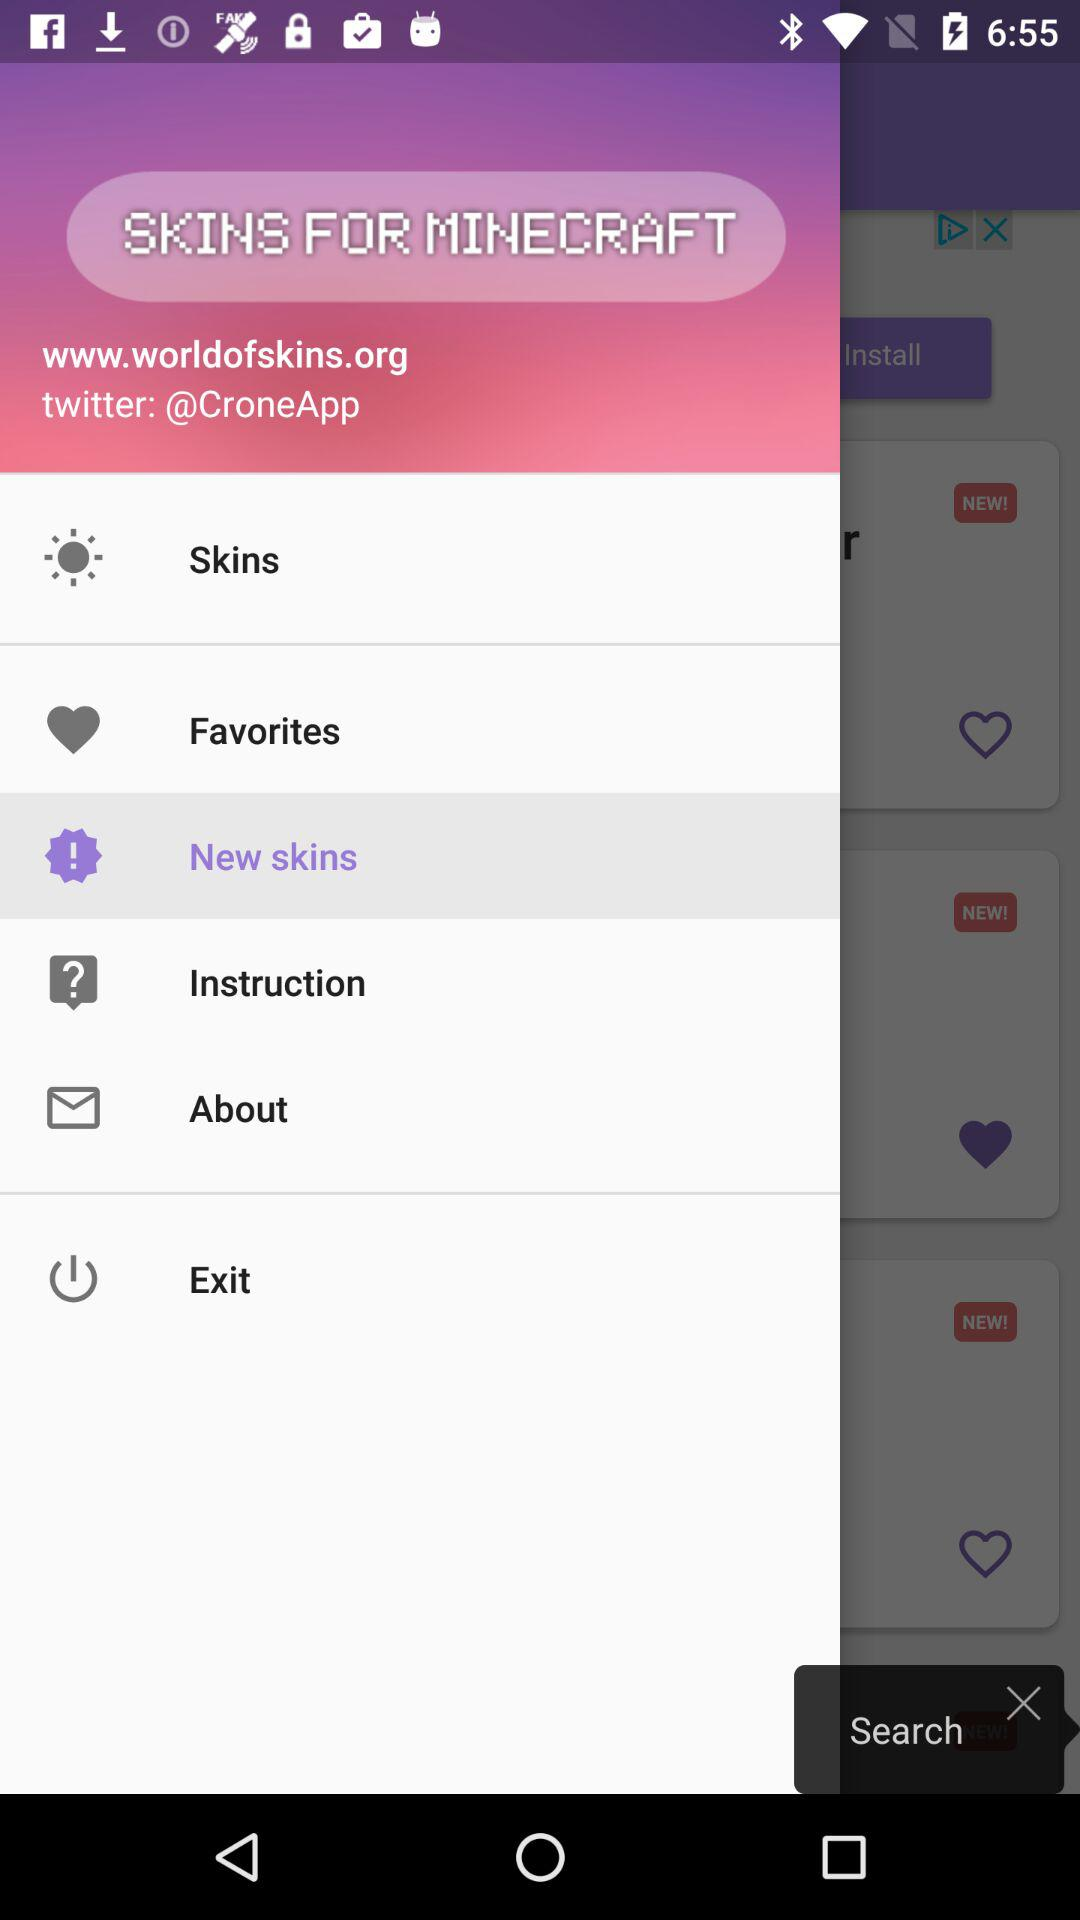How many notifications are there in "Favorites"?
When the provided information is insufficient, respond with <no answer>. <no answer> 